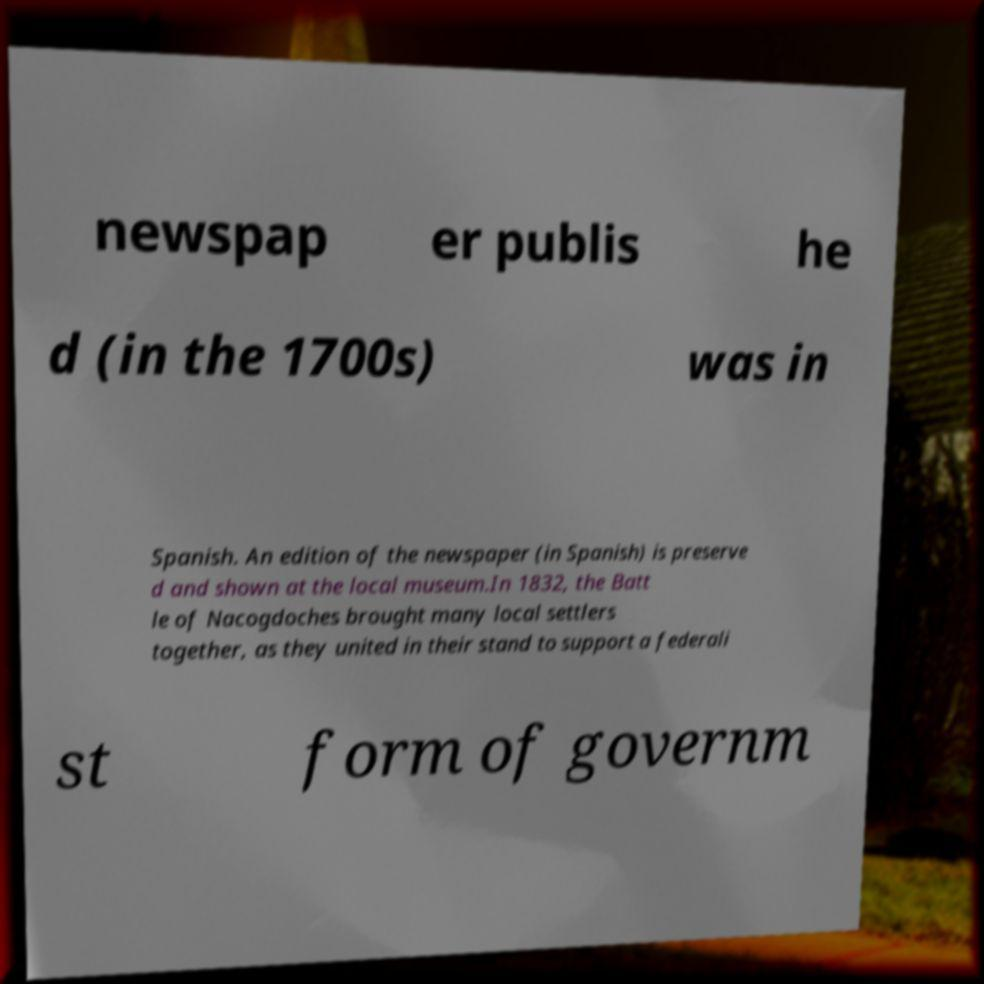Could you assist in decoding the text presented in this image and type it out clearly? newspap er publis he d (in the 1700s) was in Spanish. An edition of the newspaper (in Spanish) is preserve d and shown at the local museum.In 1832, the Batt le of Nacogdoches brought many local settlers together, as they united in their stand to support a federali st form of governm 